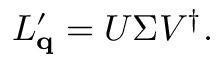Convert formula to latex. <formula><loc_0><loc_0><loc_500><loc_500>\begin{array} { r } { L _ { \mathbf q } ^ { \prime } = U \Sigma V ^ { \dagger } . } \end{array}</formula> 